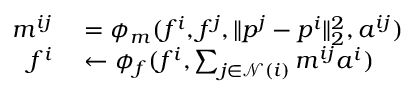<formula> <loc_0><loc_0><loc_500><loc_500>\begin{array} { r l } { m ^ { i j } } & = \phi _ { m } ( f ^ { i } , f ^ { j } , \| p ^ { j } - p ^ { i } \| _ { 2 } ^ { 2 } , a ^ { i j } ) } \\ { f ^ { i } } & \leftarrow \phi _ { f } ( f ^ { i } , \sum _ { j \in \mathcal { N } ( i ) } m ^ { i j } a ^ { i } ) } \end{array}</formula> 